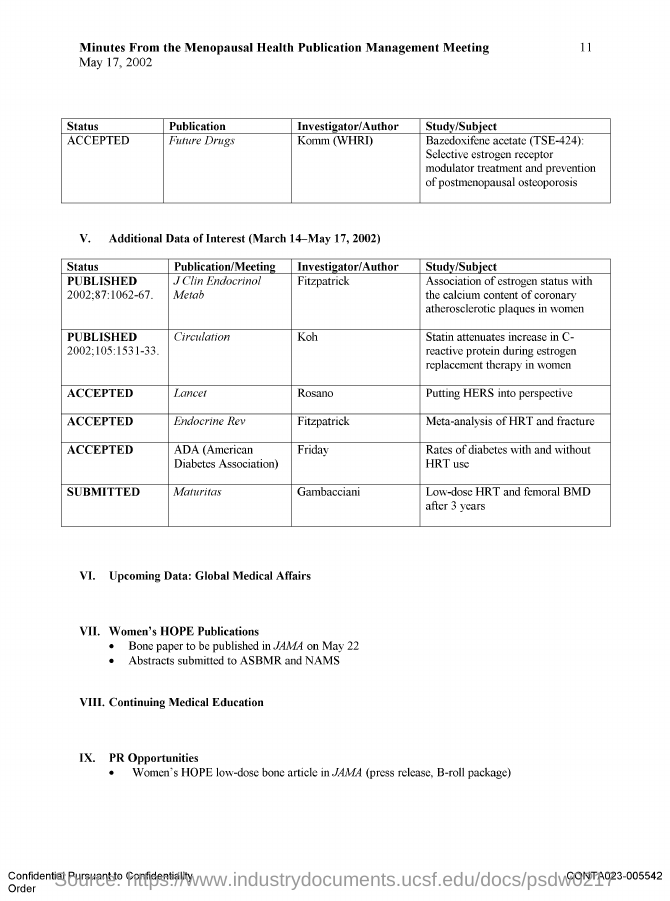Point out several critical features in this image. The date of the Minutes from the Menopausal Health Publication Management Meeting is May 17, 2002. The publication "Future Drugs" has been accepted. The study titled "Meta-analysis of HRT and fracture" was authored by Fitzpatrick. The study titled "Putting HERS into perspective" was authored by Rosano. 